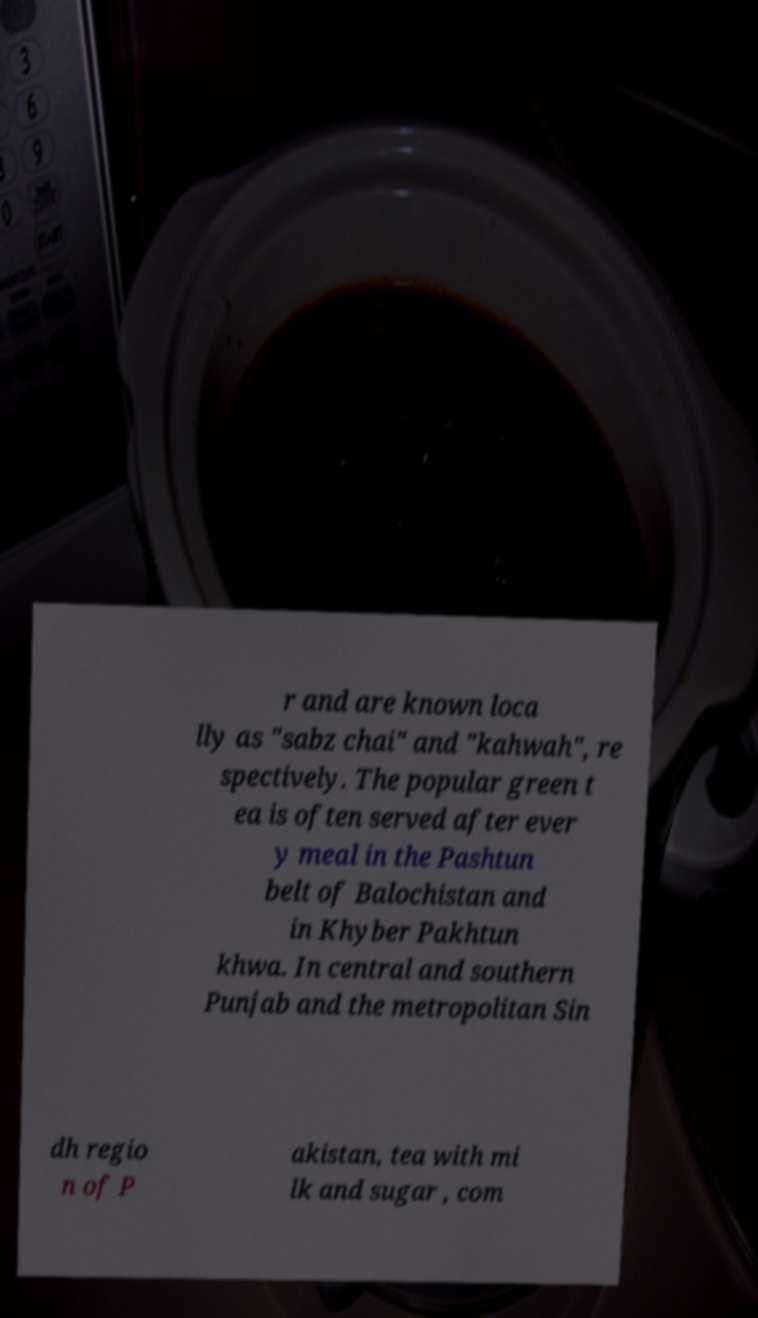Could you assist in decoding the text presented in this image and type it out clearly? r and are known loca lly as "sabz chai" and "kahwah", re spectively. The popular green t ea is often served after ever y meal in the Pashtun belt of Balochistan and in Khyber Pakhtun khwa. In central and southern Punjab and the metropolitan Sin dh regio n of P akistan, tea with mi lk and sugar , com 